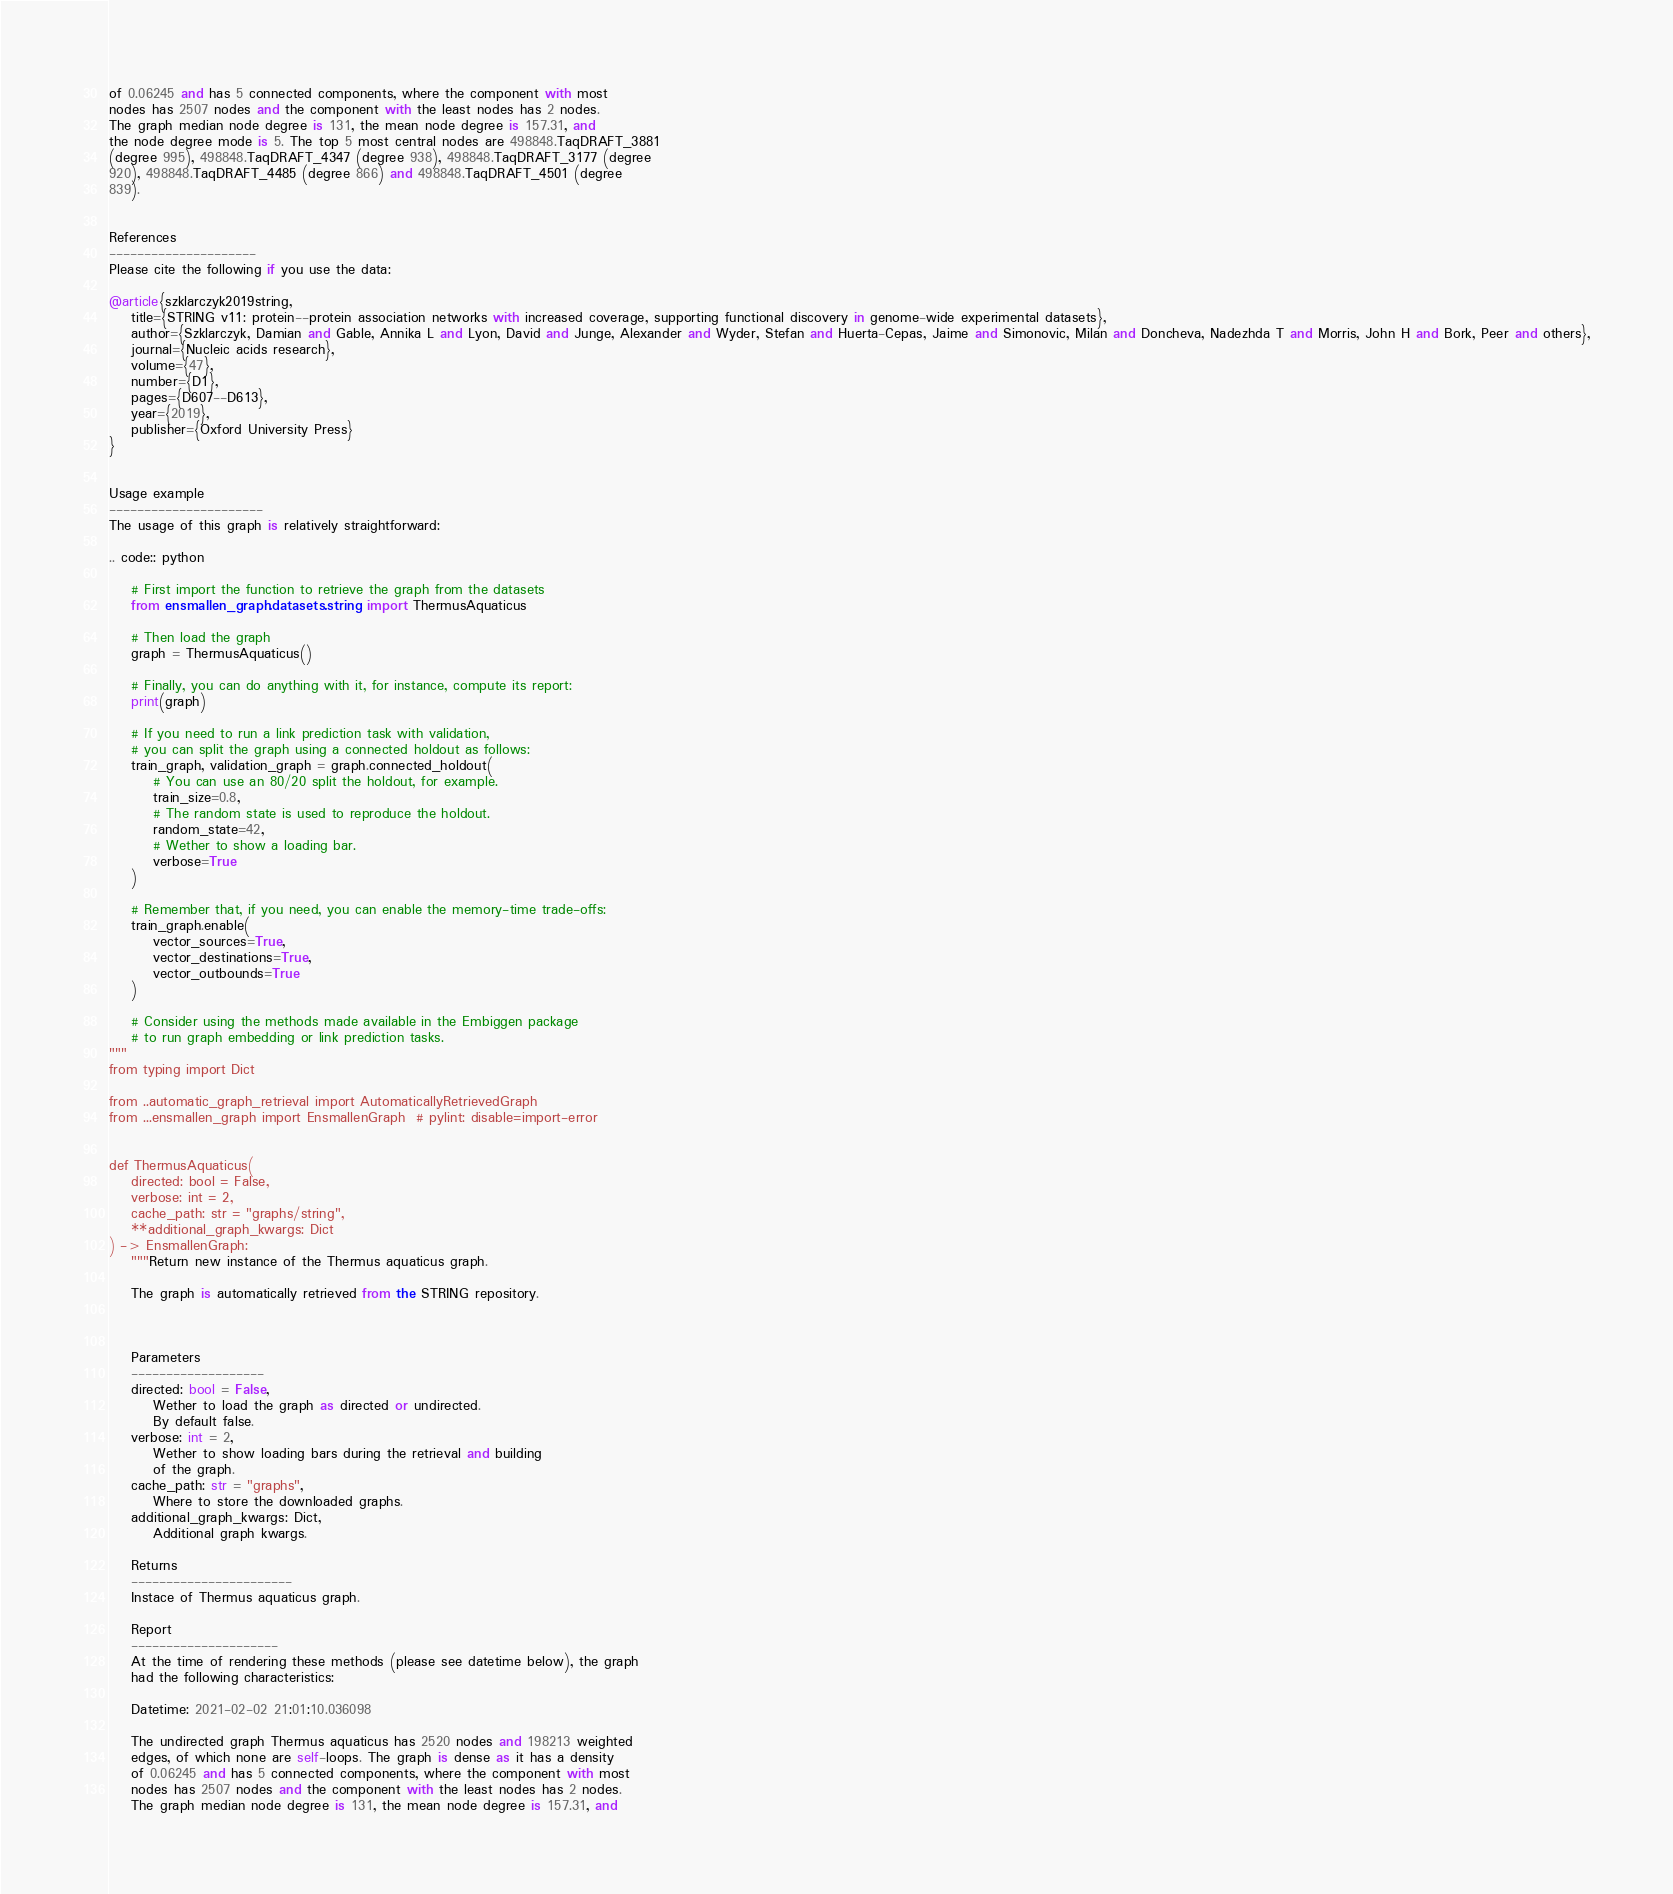Convert code to text. <code><loc_0><loc_0><loc_500><loc_500><_Python_>of 0.06245 and has 5 connected components, where the component with most
nodes has 2507 nodes and the component with the least nodes has 2 nodes.
The graph median node degree is 131, the mean node degree is 157.31, and
the node degree mode is 5. The top 5 most central nodes are 498848.TaqDRAFT_3881
(degree 995), 498848.TaqDRAFT_4347 (degree 938), 498848.TaqDRAFT_3177 (degree
920), 498848.TaqDRAFT_4485 (degree 866) and 498848.TaqDRAFT_4501 (degree
839).


References
---------------------
Please cite the following if you use the data:

@article{szklarczyk2019string,
    title={STRING v11: protein--protein association networks with increased coverage, supporting functional discovery in genome-wide experimental datasets},
    author={Szklarczyk, Damian and Gable, Annika L and Lyon, David and Junge, Alexander and Wyder, Stefan and Huerta-Cepas, Jaime and Simonovic, Milan and Doncheva, Nadezhda T and Morris, John H and Bork, Peer and others},
    journal={Nucleic acids research},
    volume={47},
    number={D1},
    pages={D607--D613},
    year={2019},
    publisher={Oxford University Press}
}


Usage example
----------------------
The usage of this graph is relatively straightforward:

.. code:: python

    # First import the function to retrieve the graph from the datasets
    from ensmallen_graph.datasets.string import ThermusAquaticus

    # Then load the graph
    graph = ThermusAquaticus()

    # Finally, you can do anything with it, for instance, compute its report:
    print(graph)

    # If you need to run a link prediction task with validation,
    # you can split the graph using a connected holdout as follows:
    train_graph, validation_graph = graph.connected_holdout(
        # You can use an 80/20 split the holdout, for example.
        train_size=0.8,
        # The random state is used to reproduce the holdout.
        random_state=42,
        # Wether to show a loading bar.
        verbose=True
    )

    # Remember that, if you need, you can enable the memory-time trade-offs:
    train_graph.enable(
        vector_sources=True,
        vector_destinations=True,
        vector_outbounds=True
    )

    # Consider using the methods made available in the Embiggen package
    # to run graph embedding or link prediction tasks.
"""
from typing import Dict

from ..automatic_graph_retrieval import AutomaticallyRetrievedGraph
from ...ensmallen_graph import EnsmallenGraph  # pylint: disable=import-error


def ThermusAquaticus(
    directed: bool = False,
    verbose: int = 2,
    cache_path: str = "graphs/string",
    **additional_graph_kwargs: Dict
) -> EnsmallenGraph:
    """Return new instance of the Thermus aquaticus graph.

    The graph is automatically retrieved from the STRING repository. 

	

    Parameters
    -------------------
    directed: bool = False,
        Wether to load the graph as directed or undirected.
        By default false.
    verbose: int = 2,
        Wether to show loading bars during the retrieval and building
        of the graph.
    cache_path: str = "graphs",
        Where to store the downloaded graphs.
    additional_graph_kwargs: Dict,
        Additional graph kwargs.

    Returns
    -----------------------
    Instace of Thermus aquaticus graph.

	Report
	---------------------
	At the time of rendering these methods (please see datetime below), the graph
	had the following characteristics:
	
	Datetime: 2021-02-02 21:01:10.036098
	
	The undirected graph Thermus aquaticus has 2520 nodes and 198213 weighted
	edges, of which none are self-loops. The graph is dense as it has a density
	of 0.06245 and has 5 connected components, where the component with most
	nodes has 2507 nodes and the component with the least nodes has 2 nodes.
	The graph median node degree is 131, the mean node degree is 157.31, and</code> 